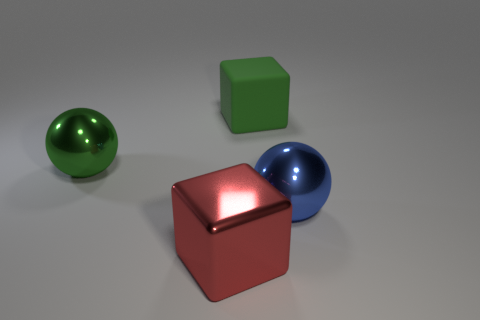There is a large block behind the red metallic thing; what material is it?
Keep it short and to the point. Rubber. Does the large red metallic object have the same shape as the large metal object left of the red shiny cube?
Make the answer very short. No. The thing that is both behind the blue thing and in front of the green matte thing is made of what material?
Provide a succinct answer. Metal. There is a metal block that is the same size as the green matte object; what is its color?
Your response must be concise. Red. Is the large green ball made of the same material as the big block that is behind the big blue thing?
Provide a succinct answer. No. How many other things are there of the same size as the blue metal ball?
Keep it short and to the point. 3. Are there any green rubber blocks that are behind the cube in front of the large object behind the green metallic ball?
Provide a short and direct response. Yes. What is the size of the cube that is right of the big metal cube?
Make the answer very short. Large. Do the cube that is left of the green matte thing and the big matte cube have the same size?
Provide a short and direct response. Yes. Are there any other things that are the same color as the big shiny cube?
Keep it short and to the point. No. 